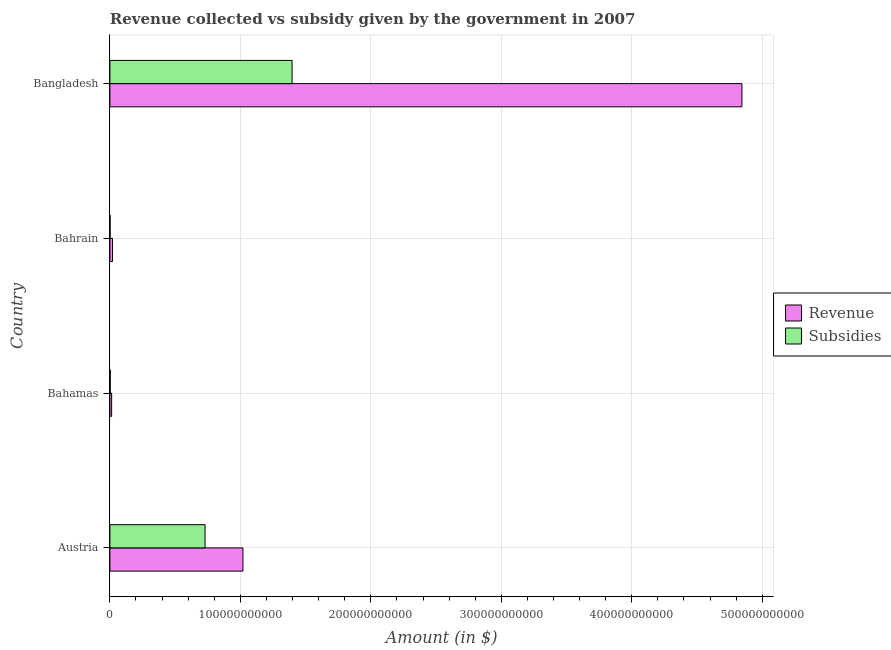How many groups of bars are there?
Ensure brevity in your answer.  4. Are the number of bars per tick equal to the number of legend labels?
Provide a short and direct response. Yes. How many bars are there on the 4th tick from the bottom?
Make the answer very short. 2. What is the label of the 3rd group of bars from the top?
Provide a short and direct response. Bahamas. What is the amount of subsidies given in Bahrain?
Make the answer very short. 1.33e+08. Across all countries, what is the maximum amount of revenue collected?
Provide a short and direct response. 4.84e+11. Across all countries, what is the minimum amount of revenue collected?
Provide a short and direct response. 1.34e+09. In which country was the amount of subsidies given minimum?
Give a very brief answer. Bahrain. What is the total amount of subsidies given in the graph?
Your response must be concise. 2.13e+11. What is the difference between the amount of subsidies given in Austria and that in Bahrain?
Ensure brevity in your answer.  7.28e+1. What is the difference between the amount of subsidies given in Bangladesh and the amount of revenue collected in Bahrain?
Your answer should be very brief. 1.38e+11. What is the average amount of revenue collected per country?
Ensure brevity in your answer.  1.47e+11. What is the difference between the amount of subsidies given and amount of revenue collected in Bangladesh?
Provide a short and direct response. -3.45e+11. What is the ratio of the amount of subsidies given in Austria to that in Bangladesh?
Make the answer very short. 0.52. Is the amount of subsidies given in Bahamas less than that in Bangladesh?
Give a very brief answer. Yes. Is the difference between the amount of revenue collected in Bahamas and Bangladesh greater than the difference between the amount of subsidies given in Bahamas and Bangladesh?
Your answer should be very brief. No. What is the difference between the highest and the second highest amount of subsidies given?
Ensure brevity in your answer.  6.67e+1. What is the difference between the highest and the lowest amount of subsidies given?
Your answer should be very brief. 1.40e+11. Is the sum of the amount of revenue collected in Bahrain and Bangladesh greater than the maximum amount of subsidies given across all countries?
Provide a succinct answer. Yes. What does the 2nd bar from the top in Bangladesh represents?
Your answer should be compact. Revenue. What does the 1st bar from the bottom in Bahrain represents?
Your response must be concise. Revenue. How many bars are there?
Your answer should be very brief. 8. Are all the bars in the graph horizontal?
Provide a short and direct response. Yes. What is the difference between two consecutive major ticks on the X-axis?
Provide a succinct answer. 1.00e+11. Does the graph contain any zero values?
Provide a short and direct response. No. Does the graph contain grids?
Keep it short and to the point. Yes. Where does the legend appear in the graph?
Ensure brevity in your answer.  Center right. How are the legend labels stacked?
Your answer should be very brief. Vertical. What is the title of the graph?
Provide a succinct answer. Revenue collected vs subsidy given by the government in 2007. Does "Male population" appear as one of the legend labels in the graph?
Your answer should be compact. No. What is the label or title of the X-axis?
Your response must be concise. Amount (in $). What is the Amount (in $) of Revenue in Austria?
Your response must be concise. 1.02e+11. What is the Amount (in $) in Subsidies in Austria?
Your response must be concise. 7.29e+1. What is the Amount (in $) of Revenue in Bahamas?
Offer a terse response. 1.34e+09. What is the Amount (in $) in Subsidies in Bahamas?
Make the answer very short. 2.99e+08. What is the Amount (in $) of Revenue in Bahrain?
Offer a terse response. 2.00e+09. What is the Amount (in $) of Subsidies in Bahrain?
Offer a terse response. 1.33e+08. What is the Amount (in $) in Revenue in Bangladesh?
Offer a terse response. 4.84e+11. What is the Amount (in $) in Subsidies in Bangladesh?
Make the answer very short. 1.40e+11. Across all countries, what is the maximum Amount (in $) of Revenue?
Provide a short and direct response. 4.84e+11. Across all countries, what is the maximum Amount (in $) of Subsidies?
Offer a terse response. 1.40e+11. Across all countries, what is the minimum Amount (in $) of Revenue?
Provide a short and direct response. 1.34e+09. Across all countries, what is the minimum Amount (in $) of Subsidies?
Give a very brief answer. 1.33e+08. What is the total Amount (in $) in Revenue in the graph?
Your answer should be very brief. 5.90e+11. What is the total Amount (in $) of Subsidies in the graph?
Ensure brevity in your answer.  2.13e+11. What is the difference between the Amount (in $) of Revenue in Austria and that in Bahamas?
Offer a terse response. 1.01e+11. What is the difference between the Amount (in $) of Subsidies in Austria and that in Bahamas?
Ensure brevity in your answer.  7.26e+1. What is the difference between the Amount (in $) of Revenue in Austria and that in Bahrain?
Provide a short and direct response. 1.00e+11. What is the difference between the Amount (in $) of Subsidies in Austria and that in Bahrain?
Offer a terse response. 7.28e+1. What is the difference between the Amount (in $) of Revenue in Austria and that in Bangladesh?
Offer a terse response. -3.82e+11. What is the difference between the Amount (in $) in Subsidies in Austria and that in Bangladesh?
Ensure brevity in your answer.  -6.67e+1. What is the difference between the Amount (in $) of Revenue in Bahamas and that in Bahrain?
Provide a short and direct response. -6.65e+08. What is the difference between the Amount (in $) in Subsidies in Bahamas and that in Bahrain?
Your answer should be compact. 1.66e+08. What is the difference between the Amount (in $) in Revenue in Bahamas and that in Bangladesh?
Provide a succinct answer. -4.83e+11. What is the difference between the Amount (in $) of Subsidies in Bahamas and that in Bangladesh?
Your answer should be compact. -1.39e+11. What is the difference between the Amount (in $) in Revenue in Bahrain and that in Bangladesh?
Ensure brevity in your answer.  -4.82e+11. What is the difference between the Amount (in $) of Subsidies in Bahrain and that in Bangladesh?
Give a very brief answer. -1.40e+11. What is the difference between the Amount (in $) in Revenue in Austria and the Amount (in $) in Subsidies in Bahamas?
Your answer should be compact. 1.02e+11. What is the difference between the Amount (in $) in Revenue in Austria and the Amount (in $) in Subsidies in Bahrain?
Make the answer very short. 1.02e+11. What is the difference between the Amount (in $) of Revenue in Austria and the Amount (in $) of Subsidies in Bangladesh?
Make the answer very short. -3.77e+1. What is the difference between the Amount (in $) of Revenue in Bahamas and the Amount (in $) of Subsidies in Bahrain?
Offer a very short reply. 1.20e+09. What is the difference between the Amount (in $) of Revenue in Bahamas and the Amount (in $) of Subsidies in Bangladesh?
Your answer should be very brief. -1.38e+11. What is the difference between the Amount (in $) of Revenue in Bahrain and the Amount (in $) of Subsidies in Bangladesh?
Ensure brevity in your answer.  -1.38e+11. What is the average Amount (in $) of Revenue per country?
Your answer should be compact. 1.47e+11. What is the average Amount (in $) of Subsidies per country?
Provide a succinct answer. 5.33e+1. What is the difference between the Amount (in $) in Revenue and Amount (in $) in Subsidies in Austria?
Ensure brevity in your answer.  2.90e+1. What is the difference between the Amount (in $) of Revenue and Amount (in $) of Subsidies in Bahamas?
Provide a succinct answer. 1.04e+09. What is the difference between the Amount (in $) in Revenue and Amount (in $) in Subsidies in Bahrain?
Provide a short and direct response. 1.87e+09. What is the difference between the Amount (in $) of Revenue and Amount (in $) of Subsidies in Bangladesh?
Your answer should be compact. 3.45e+11. What is the ratio of the Amount (in $) in Revenue in Austria to that in Bahamas?
Ensure brevity in your answer.  76.32. What is the ratio of the Amount (in $) in Subsidies in Austria to that in Bahamas?
Offer a very short reply. 244.09. What is the ratio of the Amount (in $) of Revenue in Austria to that in Bahrain?
Your response must be concise. 50.96. What is the ratio of the Amount (in $) of Subsidies in Austria to that in Bahrain?
Your answer should be very brief. 550.21. What is the ratio of the Amount (in $) in Revenue in Austria to that in Bangladesh?
Offer a very short reply. 0.21. What is the ratio of the Amount (in $) in Subsidies in Austria to that in Bangladesh?
Keep it short and to the point. 0.52. What is the ratio of the Amount (in $) of Revenue in Bahamas to that in Bahrain?
Offer a terse response. 0.67. What is the ratio of the Amount (in $) in Subsidies in Bahamas to that in Bahrain?
Give a very brief answer. 2.25. What is the ratio of the Amount (in $) of Revenue in Bahamas to that in Bangladesh?
Offer a terse response. 0. What is the ratio of the Amount (in $) of Subsidies in Bahamas to that in Bangladesh?
Offer a terse response. 0. What is the ratio of the Amount (in $) of Revenue in Bahrain to that in Bangladesh?
Offer a very short reply. 0. What is the ratio of the Amount (in $) of Subsidies in Bahrain to that in Bangladesh?
Your answer should be compact. 0. What is the difference between the highest and the second highest Amount (in $) in Revenue?
Offer a terse response. 3.82e+11. What is the difference between the highest and the second highest Amount (in $) of Subsidies?
Provide a succinct answer. 6.67e+1. What is the difference between the highest and the lowest Amount (in $) in Revenue?
Keep it short and to the point. 4.83e+11. What is the difference between the highest and the lowest Amount (in $) of Subsidies?
Your answer should be compact. 1.40e+11. 